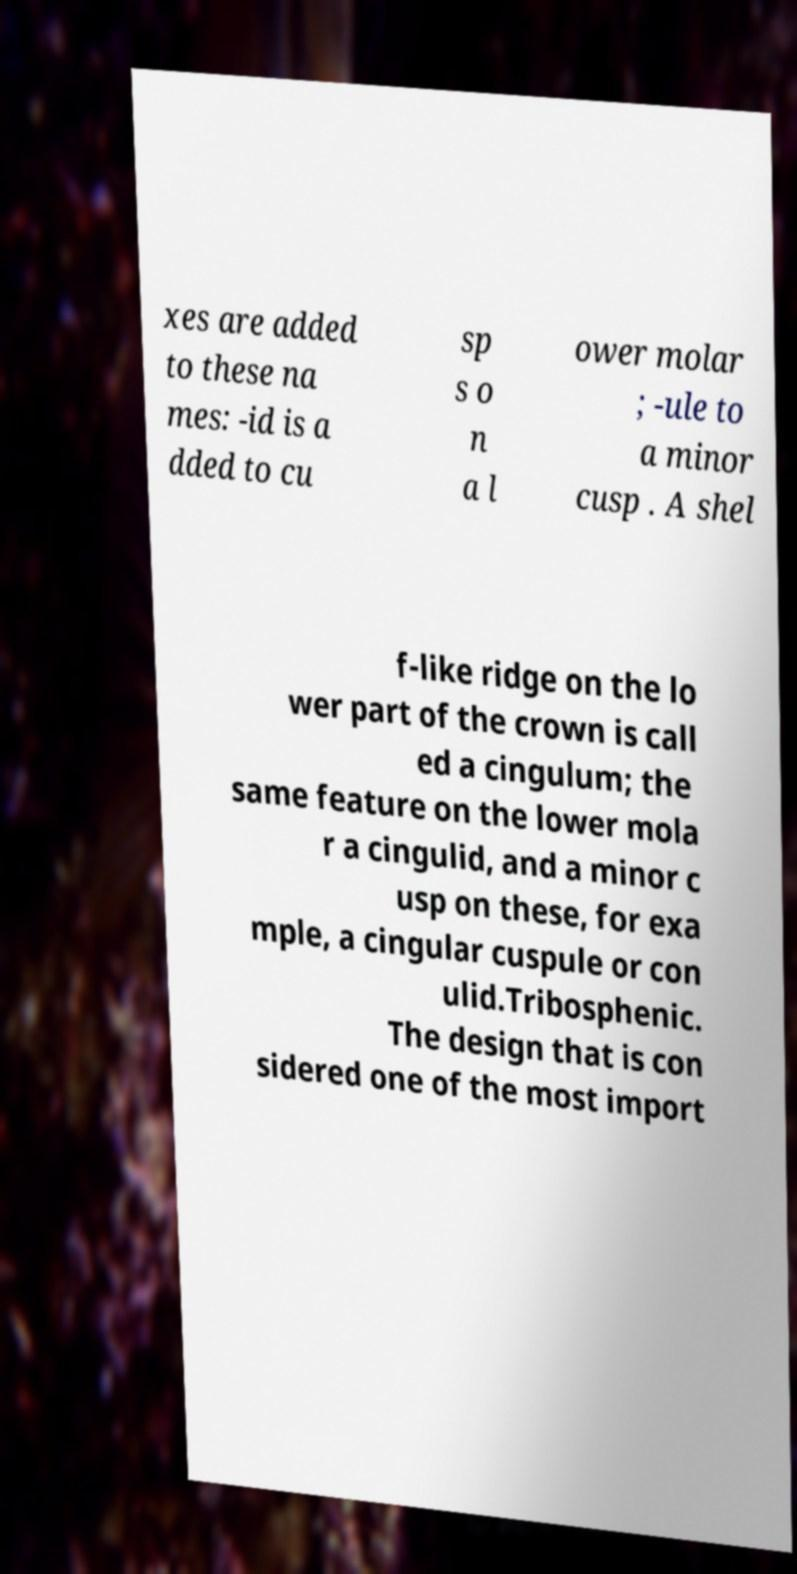Please identify and transcribe the text found in this image. xes are added to these na mes: -id is a dded to cu sp s o n a l ower molar ; -ule to a minor cusp . A shel f-like ridge on the lo wer part of the crown is call ed a cingulum; the same feature on the lower mola r a cingulid, and a minor c usp on these, for exa mple, a cingular cuspule or con ulid.Tribosphenic. The design that is con sidered one of the most import 